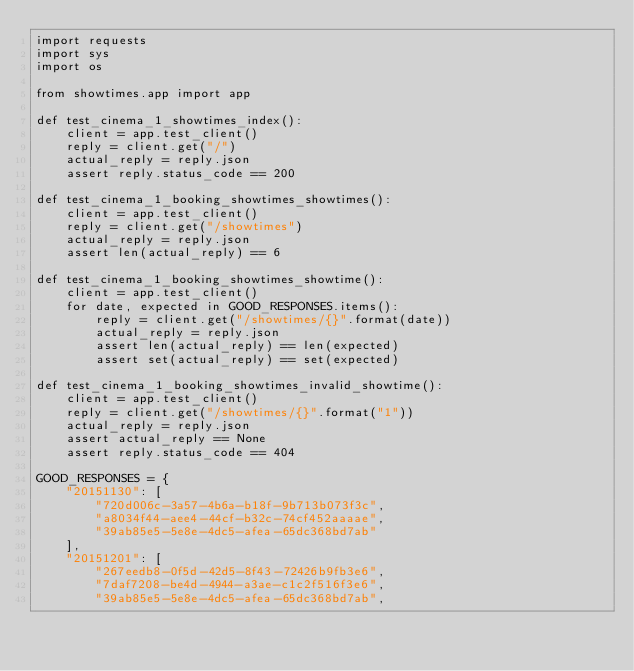Convert code to text. <code><loc_0><loc_0><loc_500><loc_500><_Python_>import requests
import sys
import os

from showtimes.app import app

def test_cinema_1_showtimes_index():
    client = app.test_client()
    reply = client.get("/")
    actual_reply = reply.json
    assert reply.status_code == 200

def test_cinema_1_booking_showtimes_showtimes():
    client = app.test_client()
    reply = client.get("/showtimes")
    actual_reply = reply.json
    assert len(actual_reply) == 6

def test_cinema_1_booking_showtimes_showtime():
    client = app.test_client()
    for date, expected in GOOD_RESPONSES.items():
        reply = client.get("/showtimes/{}".format(date))
        actual_reply = reply.json
        assert len(actual_reply) == len(expected)
        assert set(actual_reply) == set(expected)

def test_cinema_1_booking_showtimes_invalid_showtime():
    client = app.test_client()
    reply = client.get("/showtimes/{}".format("1"))
    actual_reply = reply.json
    assert actual_reply == None
    assert reply.status_code == 404

GOOD_RESPONSES = {
    "20151130": [
        "720d006c-3a57-4b6a-b18f-9b713b073f3c",
        "a8034f44-aee4-44cf-b32c-74cf452aaaae",
        "39ab85e5-5e8e-4dc5-afea-65dc368bd7ab"
    ],
    "20151201": [
        "267eedb8-0f5d-42d5-8f43-72426b9fb3e6",
        "7daf7208-be4d-4944-a3ae-c1c2f516f3e6",
        "39ab85e5-5e8e-4dc5-afea-65dc368bd7ab",</code> 